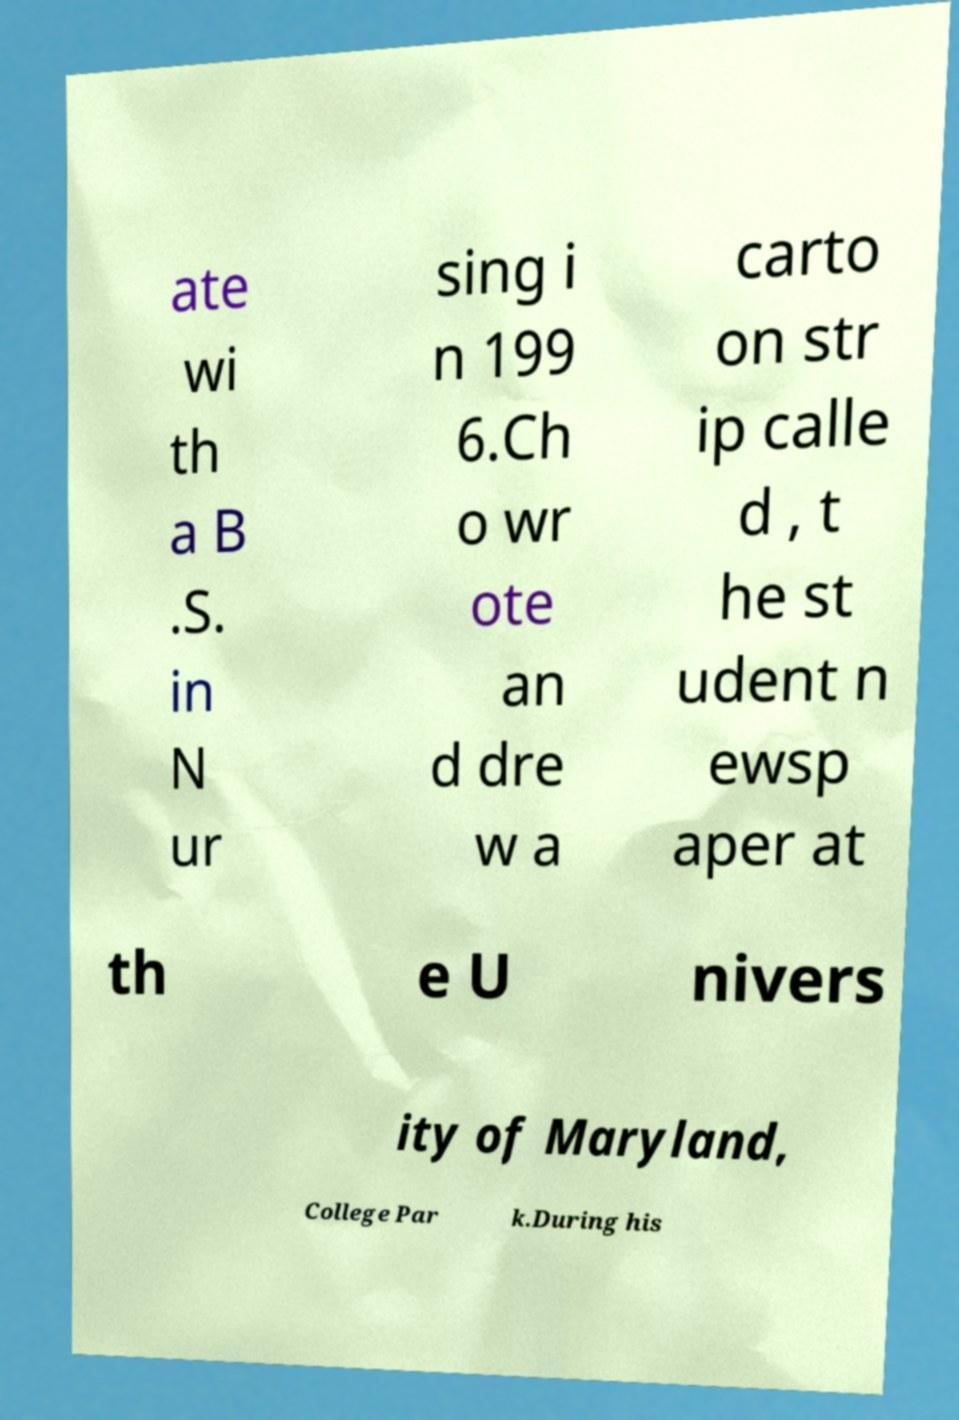There's text embedded in this image that I need extracted. Can you transcribe it verbatim? ate wi th a B .S. in N ur sing i n 199 6.Ch o wr ote an d dre w a carto on str ip calle d , t he st udent n ewsp aper at th e U nivers ity of Maryland, College Par k.During his 